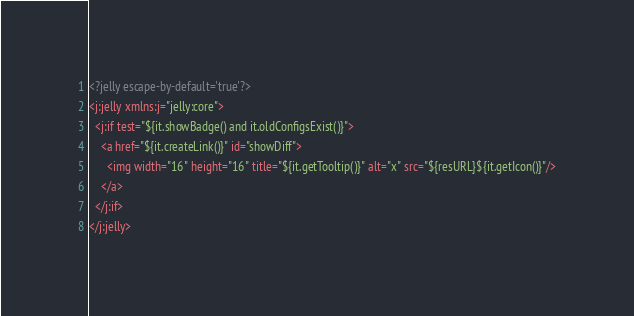<code> <loc_0><loc_0><loc_500><loc_500><_XML_><?jelly escape-by-default='true'?>
<j:jelly xmlns:j="jelly:core">
  <j:if test="${it.showBadge() and it.oldConfigsExist()}">
    <a href="${it.createLink()}" id="showDiff">
      <img width="16" height="16" title="${it.getTooltip()}" alt="x" src="${resURL}${it.getIcon()}"/>
    </a>
  </j:if>
</j:jelly>
</code> 